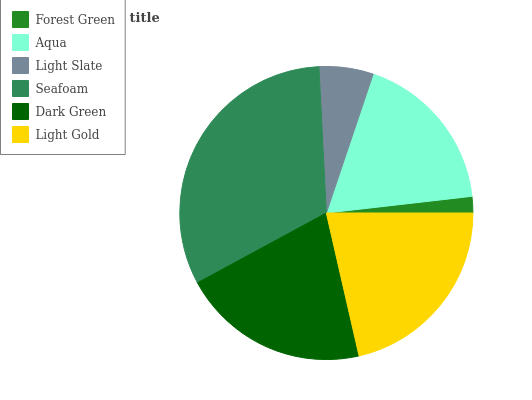Is Forest Green the minimum?
Answer yes or no. Yes. Is Seafoam the maximum?
Answer yes or no. Yes. Is Aqua the minimum?
Answer yes or no. No. Is Aqua the maximum?
Answer yes or no. No. Is Aqua greater than Forest Green?
Answer yes or no. Yes. Is Forest Green less than Aqua?
Answer yes or no. Yes. Is Forest Green greater than Aqua?
Answer yes or no. No. Is Aqua less than Forest Green?
Answer yes or no. No. Is Dark Green the high median?
Answer yes or no. Yes. Is Aqua the low median?
Answer yes or no. Yes. Is Aqua the high median?
Answer yes or no. No. Is Dark Green the low median?
Answer yes or no. No. 